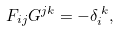<formula> <loc_0><loc_0><loc_500><loc_500>F _ { i j } G ^ { j k } = - \delta _ { i } ^ { \, k } ,</formula> 